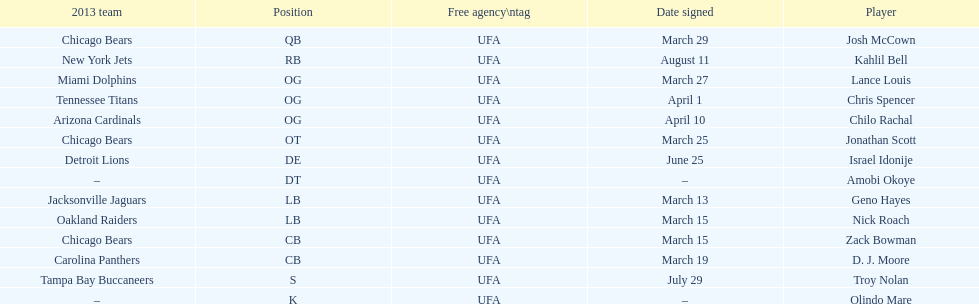His/her first name is the same name as a country. Israel Idonije. 